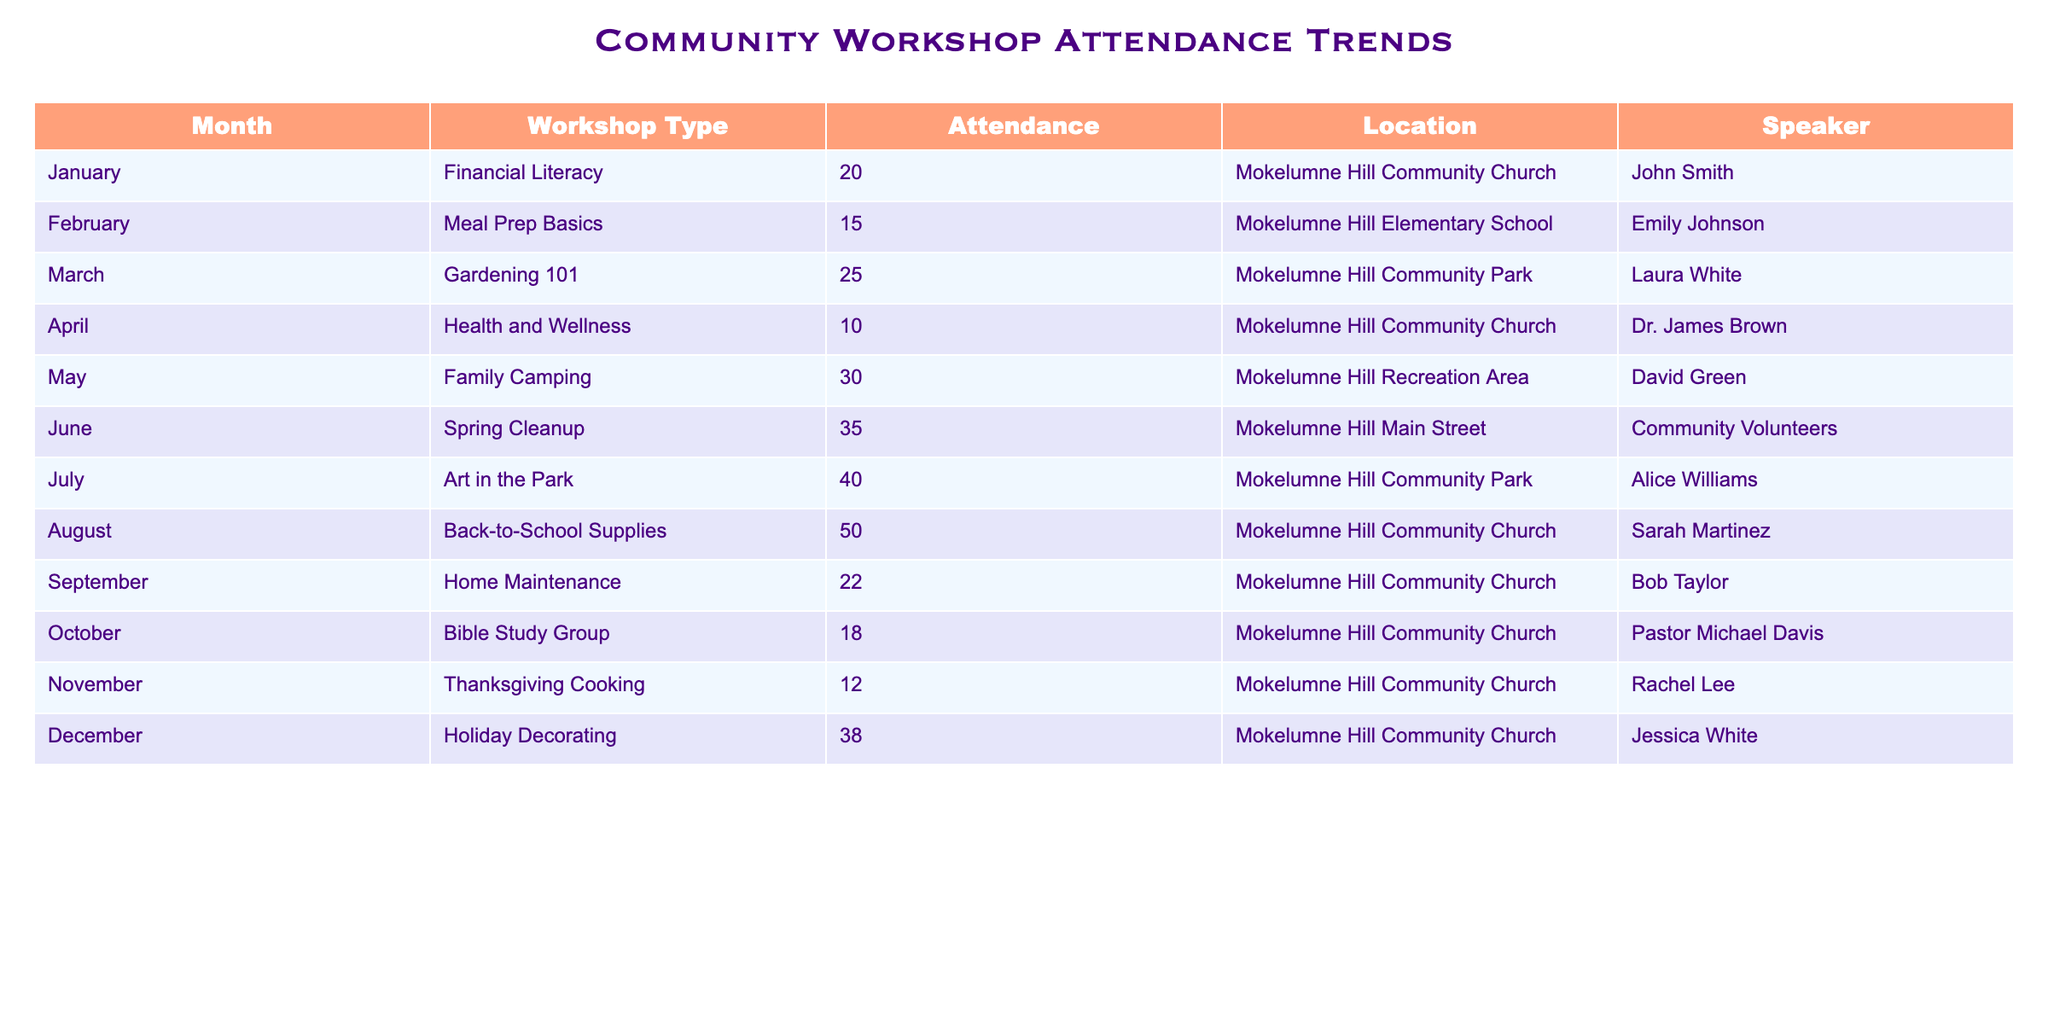What was the highest attendance for a workshop in 2023? The table shows attendance figures for each workshop by month. Scanning down the Attendance column, the highest value is 50 in August for the Back-to-School Supplies workshop.
Answer: 50 Which month had the lowest attendance and what was the number? Looking at the Attendance values, the lowest attendance is 10 in April for the Health and Wellness workshop.
Answer: 10 in April What is the average attendance of workshops held at the Mokelumne Hill Community Church? Filtering the table to only include workshops held at the Mokelumne Hill Community Church, the relevant attendances are 20, 10, 50, 22, 18, and 12. Summing these gives 132 (20+10+50+22+18+12) and dividing by the 6 workshops results in an average attendance of 22.
Answer: 22 Was there a workshop in March, and if so, what was the attendance? Checking the table, there is indeed a workshop listed for March (Gardening 101) with an attendance of 25.
Answer: Yes, 25 What total attendance was recorded across all workshops from January to June? Adding the attendance figures from January (20), February (15), March (25), April (10), May (30), and June (35) gives 135 (20+15+25+10+30+35).
Answer: 135 How many more attendees were there in August compared to the attendance in November? In August, the attendance was 50 and in November it was 12. The difference is 50 - 12 = 38.
Answer: 38 Which workshop had the most attendees in the summer months (June, July, August)? The table shows attendances of 35 in June, 40 in July, and 50 in August. Since 50 is the highest of these three values, the workshop in August (Back-to-School Supplies) had the most attendees during the summer.
Answer: Back-to-School Supplies in August Did the attendance for the workshop in September exceed the average attendance of all workshops conducted? The average attendance calculated from all the workshops is approximately 23. The attendance in September was 22, which does not exceed the average.
Answer: No In which month was the Family Camping workshop held and how does its attendance compare to the workshop with the highest attendance? The Family Camping workshop was held in May with an attendance of 30. The highest attendance was 50 in August. The difference is 50 - 30 = 20.
Answer: May, 30; 20 less than the highest 